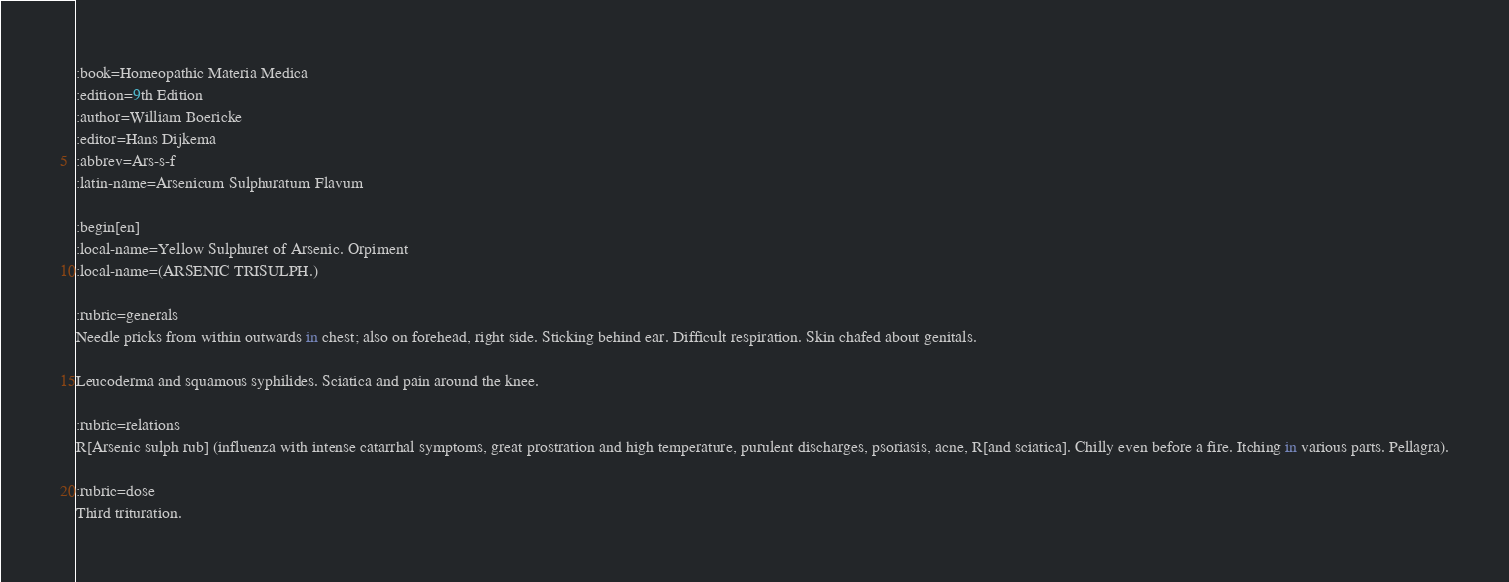<code> <loc_0><loc_0><loc_500><loc_500><_ObjectiveC_>:book=Homeopathic Materia Medica
:edition=9th Edition
:author=William Boericke
:editor=Hans Dijkema
:abbrev=Ars-s-f
:latin-name=Arsenicum Sulphuratum Flavum

:begin[en]
:local-name=Yellow Sulphuret of Arsenic. Orpiment
:local-name=(ARSENIC TRISULPH.)

:rubric=generals
Needle pricks from within outwards in chest; also on forehead, right side. Sticking behind ear. Difficult respiration. Skin chafed about genitals.

Leucoderma and squamous syphilides. Sciatica and pain around the knee.

:rubric=relations
R[Arsenic sulph rub] (influenza with intense catarrhal symptoms, great prostration and high temperature, purulent discharges, psoriasis, acne, R[and sciatica]. Chilly even before a fire. Itching in various parts. Pellagra).

:rubric=dose
Third trituration.

</code> 